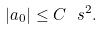<formula> <loc_0><loc_0><loc_500><loc_500>| a _ { 0 } | \leq C \ s ^ { 2 } .</formula> 